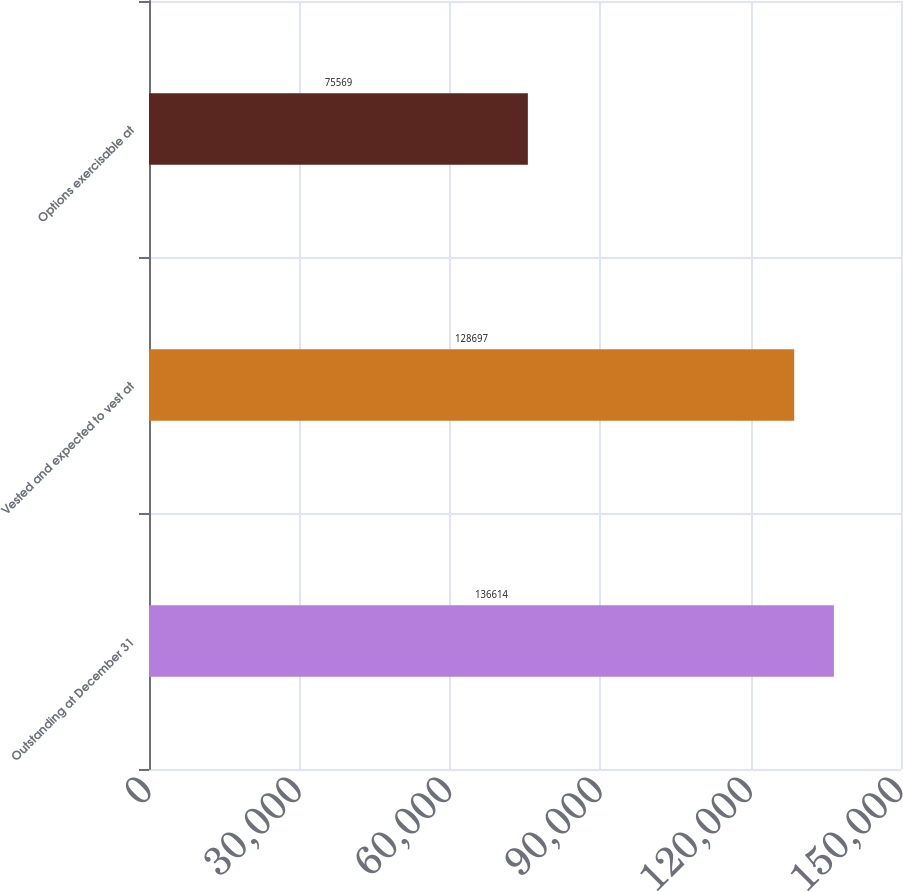Convert chart. <chart><loc_0><loc_0><loc_500><loc_500><bar_chart><fcel>Outstanding at December 31<fcel>Vested and expected to vest at<fcel>Options exercisable at<nl><fcel>136614<fcel>128697<fcel>75569<nl></chart> 